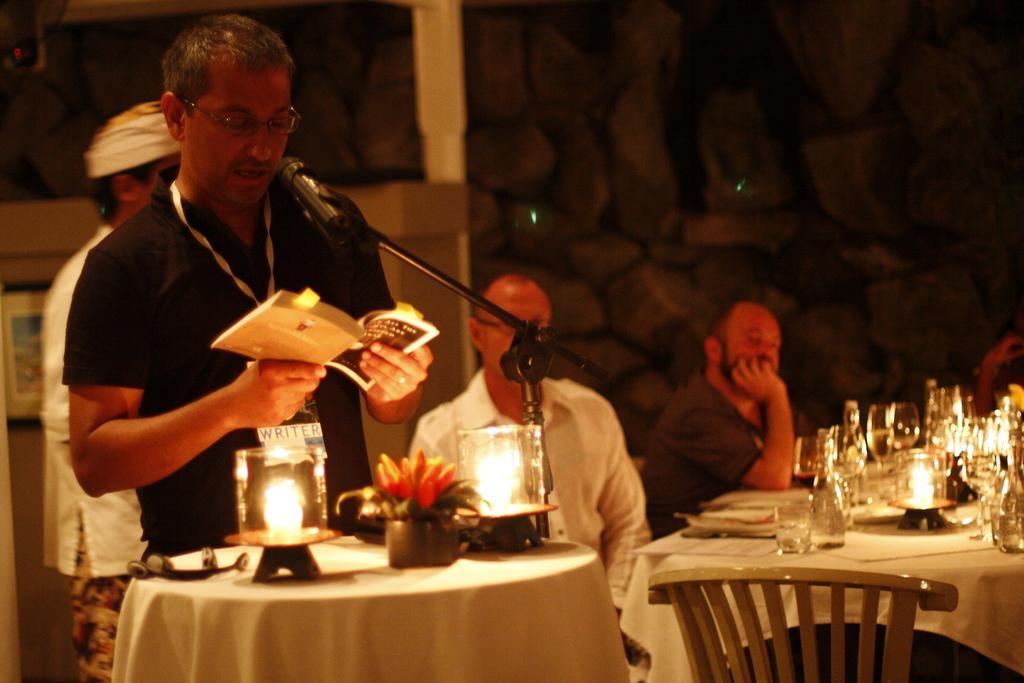Could you give a brief overview of what you see in this image? The man in black T-shirt who is wearing spectacles is holding a book in his hand and he is talking on the microphone. In front of him, we see a table on which candles and flower vase are placed. Beside him, we see two men sitting on the chairs. In front of them, we see a table which is covered with white cloth and on the table, we see glasses, glass bottles and books. Behind him, the man in white apron is standing. Behind him, we see a cupboard and a wall on which photo frame is placed. In the background, it is black in color. 